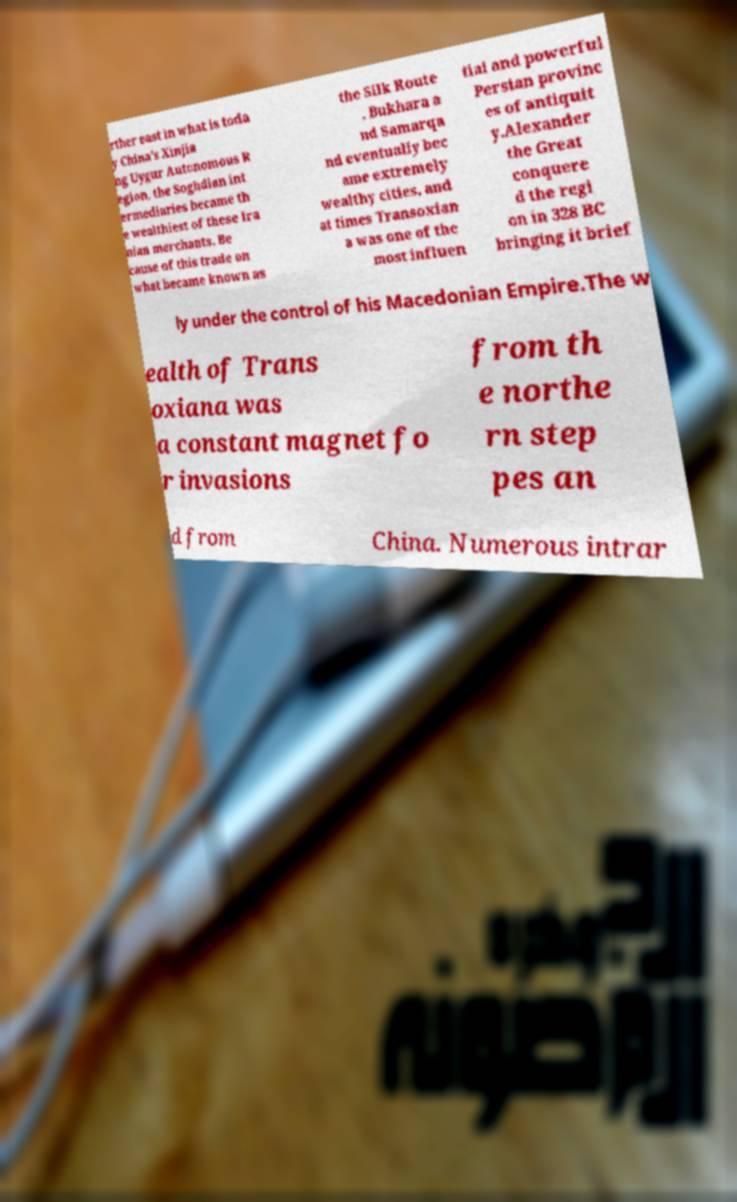There's text embedded in this image that I need extracted. Can you transcribe it verbatim? rther east in what is toda y China's Xinjia ng Uygur Autonomous R egion, the Soghdian int ermediaries became th e wealthiest of these Ira nian merchants. Be cause of this trade on what became known as the Silk Route , Bukhara a nd Samarqa nd eventually bec ame extremely wealthy cities, and at times Transoxian a was one of the most influen tial and powerful Persian provinc es of antiquit y.Alexander the Great conquere d the regi on in 328 BC bringing it brief ly under the control of his Macedonian Empire.The w ealth of Trans oxiana was a constant magnet fo r invasions from th e northe rn step pes an d from China. Numerous intrar 